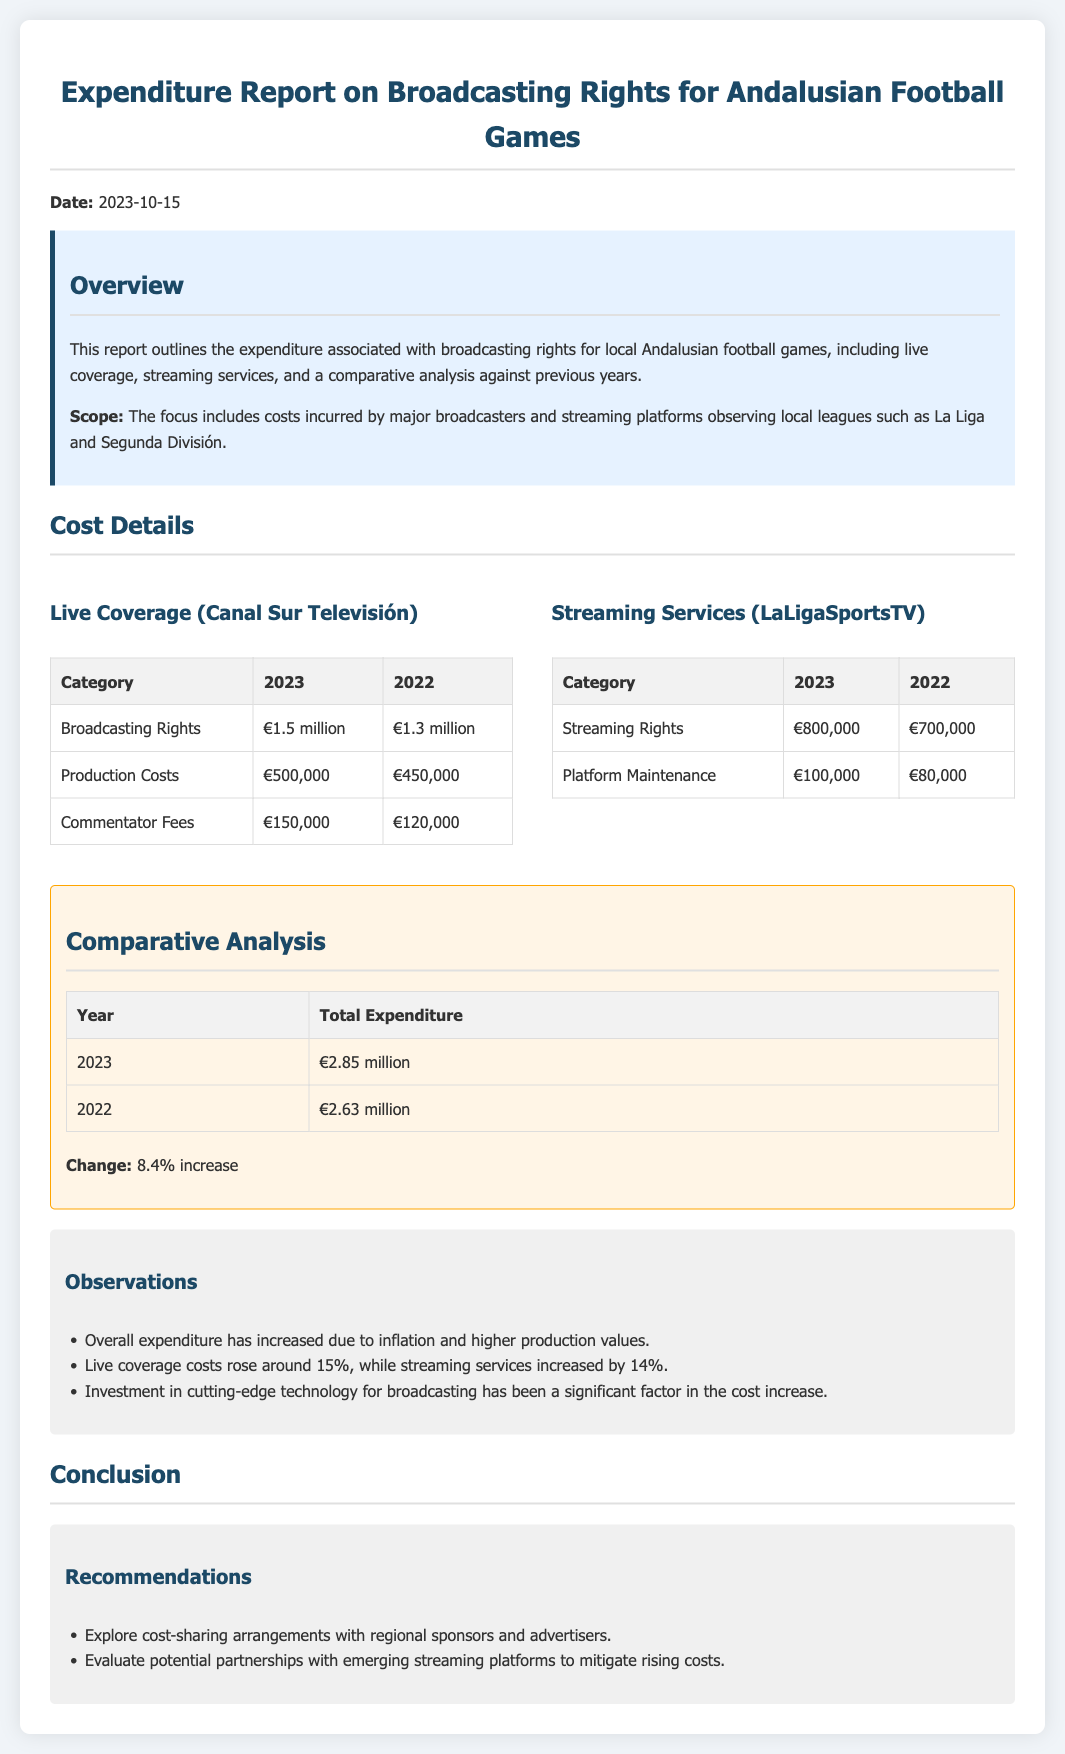What is the total expenditure for 2023? The total expenditure for 2023 is listed in the comparative analysis section of the document.
Answer: €2.85 million How much did live coverage costs rise in percentage? The document mentions that live coverage costs rose around 15%, which is part of the observations section.
Answer: 15% What are the production costs for 2023? The production costs for 2023 can be found in the cost details section under live coverage.
Answer: €500,000 What is the increase in streaming rights from 2022 to 2023? The streaming rights for 2022 and 2023 are compared in the cost details section, showing their respective amounts.
Answer: €100,000 What was the streaming service expenditure in 2022? The document provides the streaming service expenditure for 2022 in the cost details section.
Answer: €700,000 What is one recommended action to mitigate costs? The recommendations section gives suggestions on how to address rising costs, including exploring partnerships.
Answer: Explore cost-sharing arrangements What is the category with the highest expenditure in 2023? By reviewing the cost details section, the category with the highest expenditure can be identified.
Answer: Broadcasting Rights How much did commentator fees increase from 2022 to 2023? The difference in commentator fees between 2022 and 2023 is indicated in the cost details section.
Answer: €30,000 What is the total expenditure for 2022? The total expenditure for 2022 is provided in the comparative analysis section for easy reference.
Answer: €2.63 million 